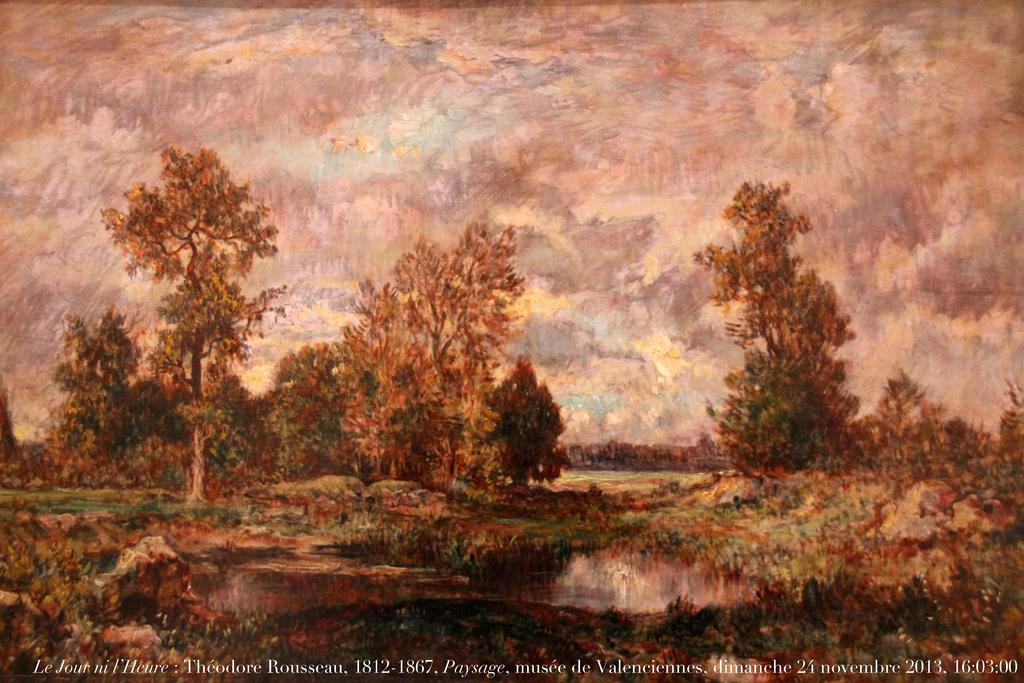What is featured in the image? There is a poster in the image. What is depicted on the poster? The poster depicts the ground, trees, and the sky with clouds. Is there any text on the poster? Yes, there is text written at the bottom of the poster. How many planes are flying in the sky on the poster? There are no planes visible in the sky on the poster; it only depicts the ground, trees, and clouds. What type of pizza is shown on the poster? There is no pizza present on the poster; it features a landscape with the ground, trees, and sky. 